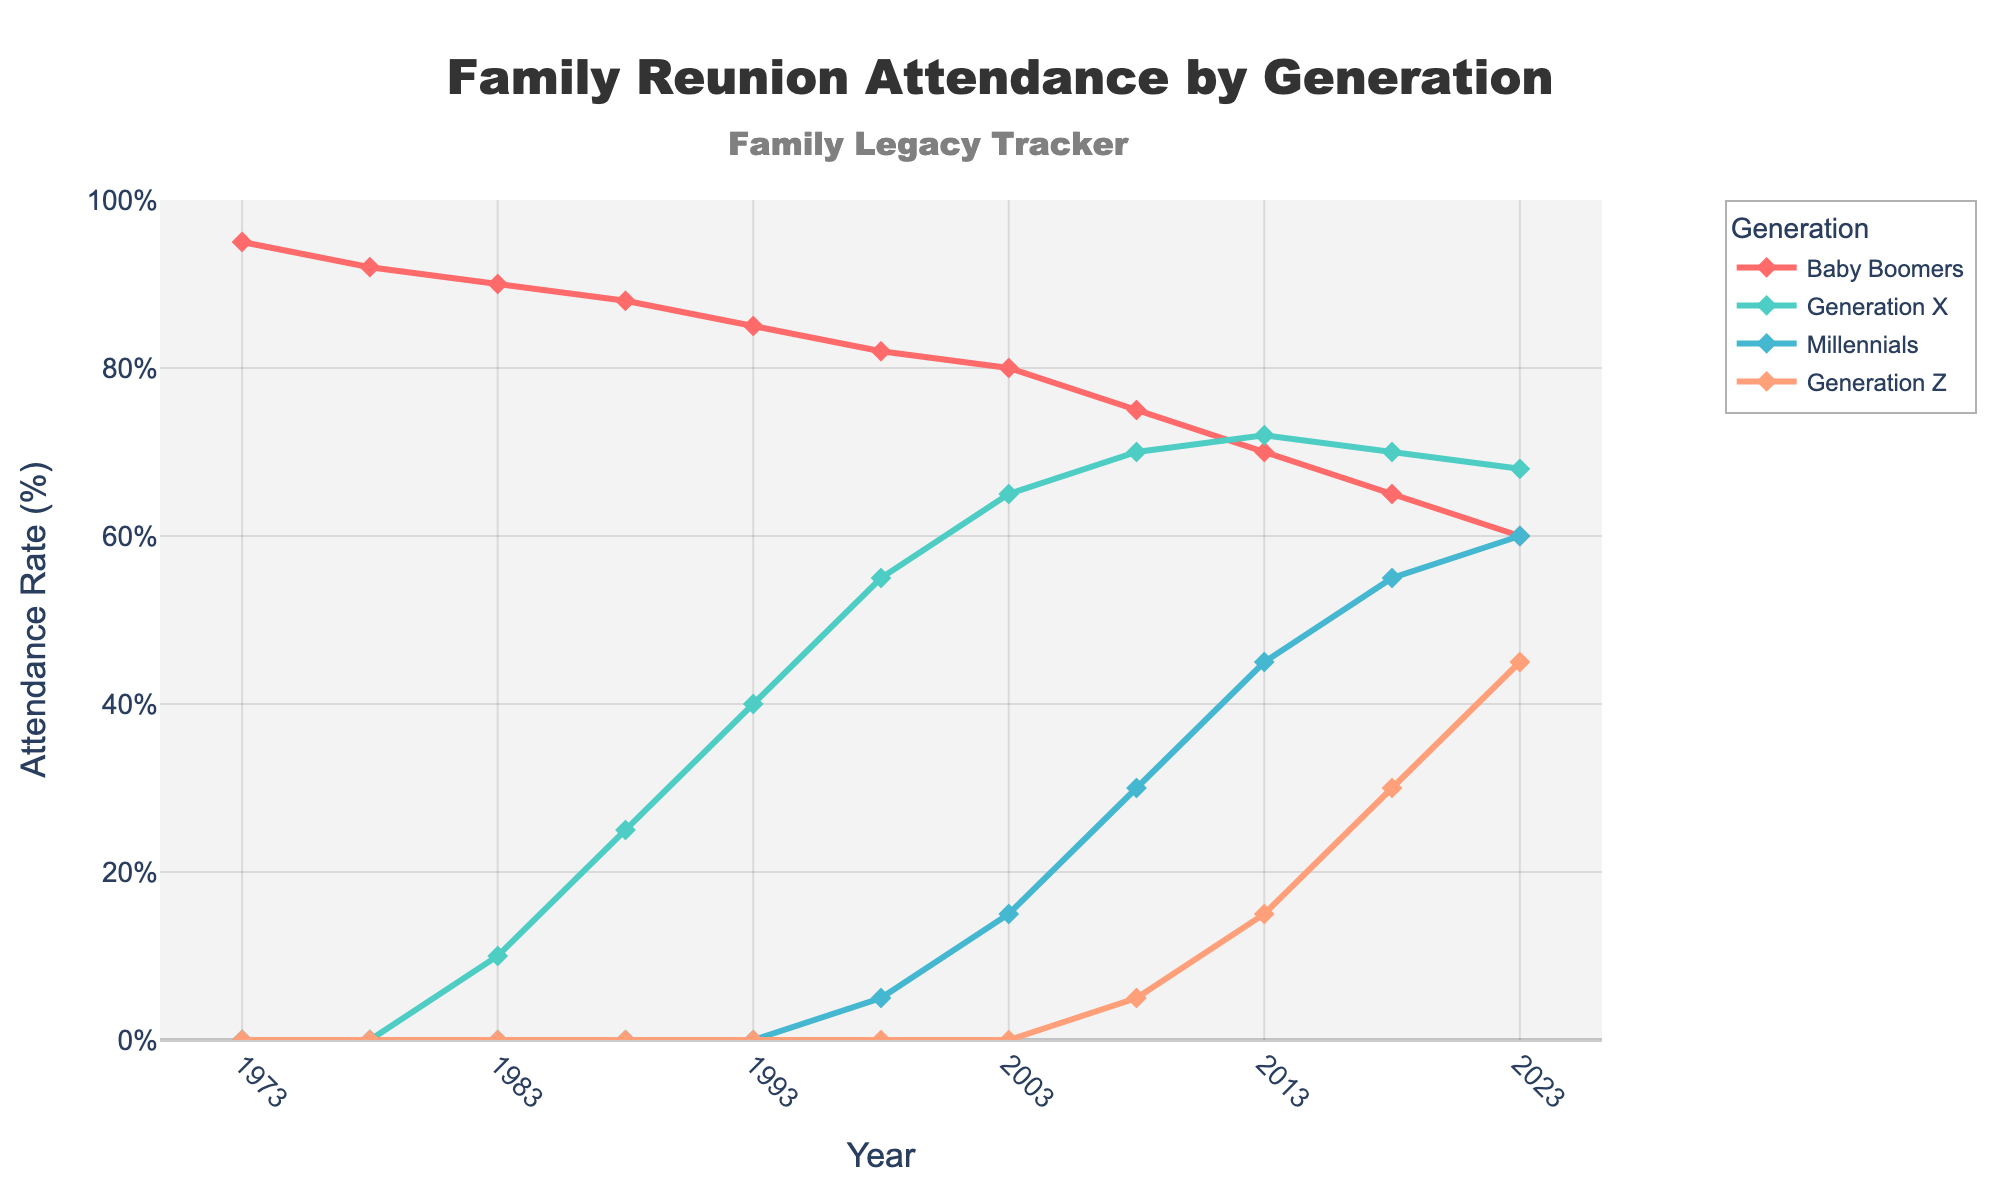What was the attendance rate for Baby Boomers in 1973 and how does it compare to Millennials in 2023? The attendance rate for Baby Boomers in 1973 is 95%, while for Millennials in 2023 it is 60%. Calculating the difference: 95% - 60% = 35%.
Answer: Baby Boomers had a 35% higher attendance rate in 1973 compared to Millennials in 2023 Which generation had the highest attendance rate in 2023? From the 2023 data: Baby Boomers 60%, Generation X 68%, Millennials 60%, and Generation Z 45%. The highest rate is for Generation X at 68%.
Answer: Generation X How did the attendance rate for Generation X change from 1983 to 2023? Attendance rate for Generation X in 1983 was 10%. In 2023, it is 68%. Change is calculated as 68% - 10% = 58%.
Answer: Increased by 58% What is the average attendance rate for Millennials over the years they are present in the data? Millennials appear from 1998 onwards: [5, 15, 30, 45, 55, 60]. Sum: 5+15+30+45+55+60 = 210. Number of years = 6. Average = 210/6 = 35%.
Answer: 35% Which generation shows the most significant drop in attendance rate from its peak to its lowest point? Analyzing the peaks and lows: Baby Boomers peak at 95% (1973) and drop to 60% (2023) for a 35% drop. Generation X peak is 72% (2013) to lowest 10% (1983) for 62% increase (negative drop). Millennials peak at 60% (2023) with no drop yet. Generation Z peak at 45% (2023) with no drop yet.
Answer: Baby Boomers with a 35% drop Which generation had a steady increase in reunion attendance from start to end in the given period and by how much? Generation X start at 10% (1983) and end at 68% (2023). Steady increase calculation: 68% - 10% = 58%.
Answer: Generation X by 58% How does the Generation Z attendance rate in 2023 compare to the Baby Boomers' attendance rate in 2008? Generation Z in 2023 is 45%. Baby Boomers in 2008 is 75%. Comparison: 75% - 45% = 30%.
Answer: Baby Boomers were 30% higher What is the average attendance rate for all generations in 2023? Attendance rates in 2023: Baby Boomers 60%, Generation X 68%, Millennials 60%, Generation Z 45%. Average = (60+68+60+45) / 4 = 58.25%.
Answer: 58.25% In which year did Millennials surpass 50% attendance rate and what was the attendance rate for Generation X in that year? Millennials surpass 50% in 2018 with a rate of 55%. Generation X rate in 2018 is 70%.
Answer: 2018, 70% What is the attendance trend for Baby Boomers from 1973 to 2023? Baby Boomers' attendance starts at 95% (1973) and decreases consistently to 60% (2023).
Answer: Decreasing 